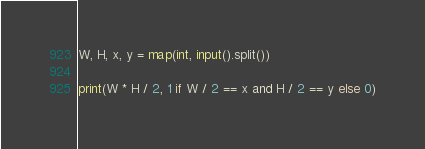<code> <loc_0><loc_0><loc_500><loc_500><_Python_>W, H, x, y = map(int, input().split())

print(W * H / 2, 1 if W / 2 == x and H / 2 == y else 0)
</code> 